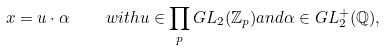Convert formula to latex. <formula><loc_0><loc_0><loc_500><loc_500>x = u \cdot \alpha \quad w i t h u \in \prod _ { p } G L _ { 2 } ( \mathbb { Z } _ { p } ) a n d \alpha \in G L _ { 2 } ^ { + } ( \mathbb { Q } ) ,</formula> 